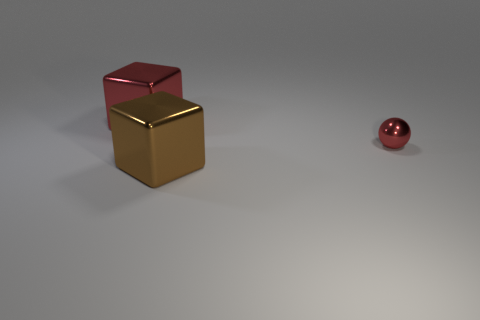There is a big object in front of the large red shiny object; what is its shape?
Provide a succinct answer. Cube. How many small shiny cylinders are the same color as the sphere?
Your answer should be compact. 0. The sphere has what color?
Your answer should be compact. Red. How many red cubes are to the right of the large metal thing that is behind the shiny ball?
Ensure brevity in your answer.  0. Do the red ball and the metallic cube in front of the big red cube have the same size?
Provide a succinct answer. No. Does the brown thing have the same size as the sphere?
Provide a succinct answer. No. Are there any metallic spheres of the same size as the brown thing?
Your answer should be compact. No. What material is the big thing behind the small red thing?
Your answer should be compact. Metal. There is a large cube that is made of the same material as the big red object; what is its color?
Keep it short and to the point. Brown. How many metallic objects are big things or large red things?
Your answer should be compact. 2. 